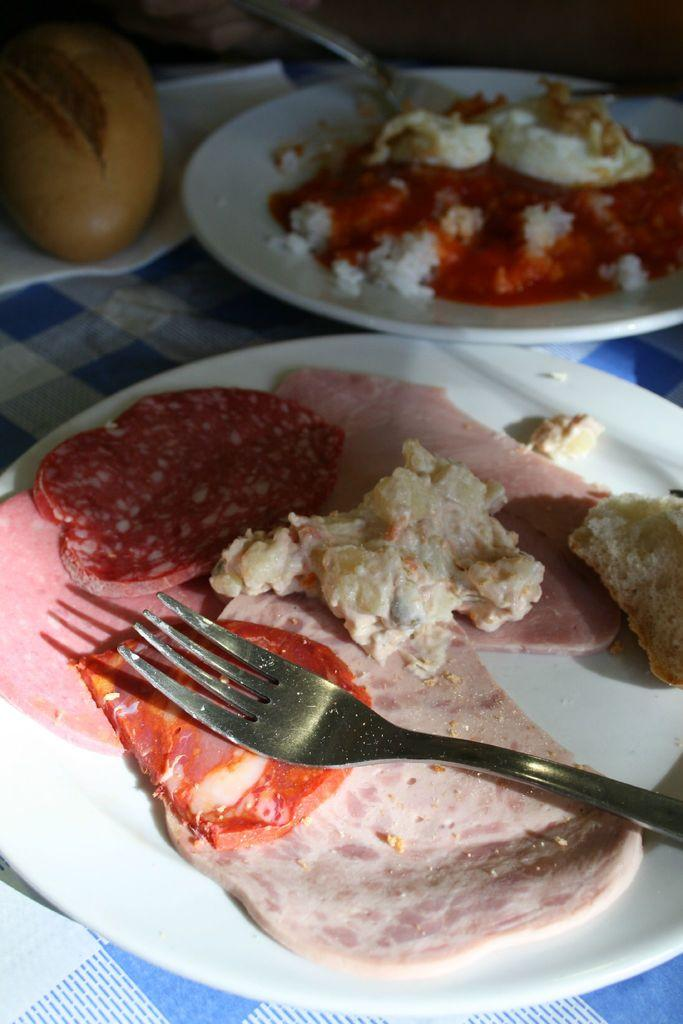What is present on the plates in the image? There are food items in plates in the image. What is the plates resting on? The plates are placed on some cloth. Can you describe the object in the top left corner of the image? Unfortunately, the facts provided do not give any information about the object in the top left corner of the image. What utensils are visible in the image? There are forks visible in the image. How many spiders are crawling on the ground in the image? There are no spiders or ground present in the image. 